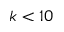<formula> <loc_0><loc_0><loc_500><loc_500>k < 1 0</formula> 